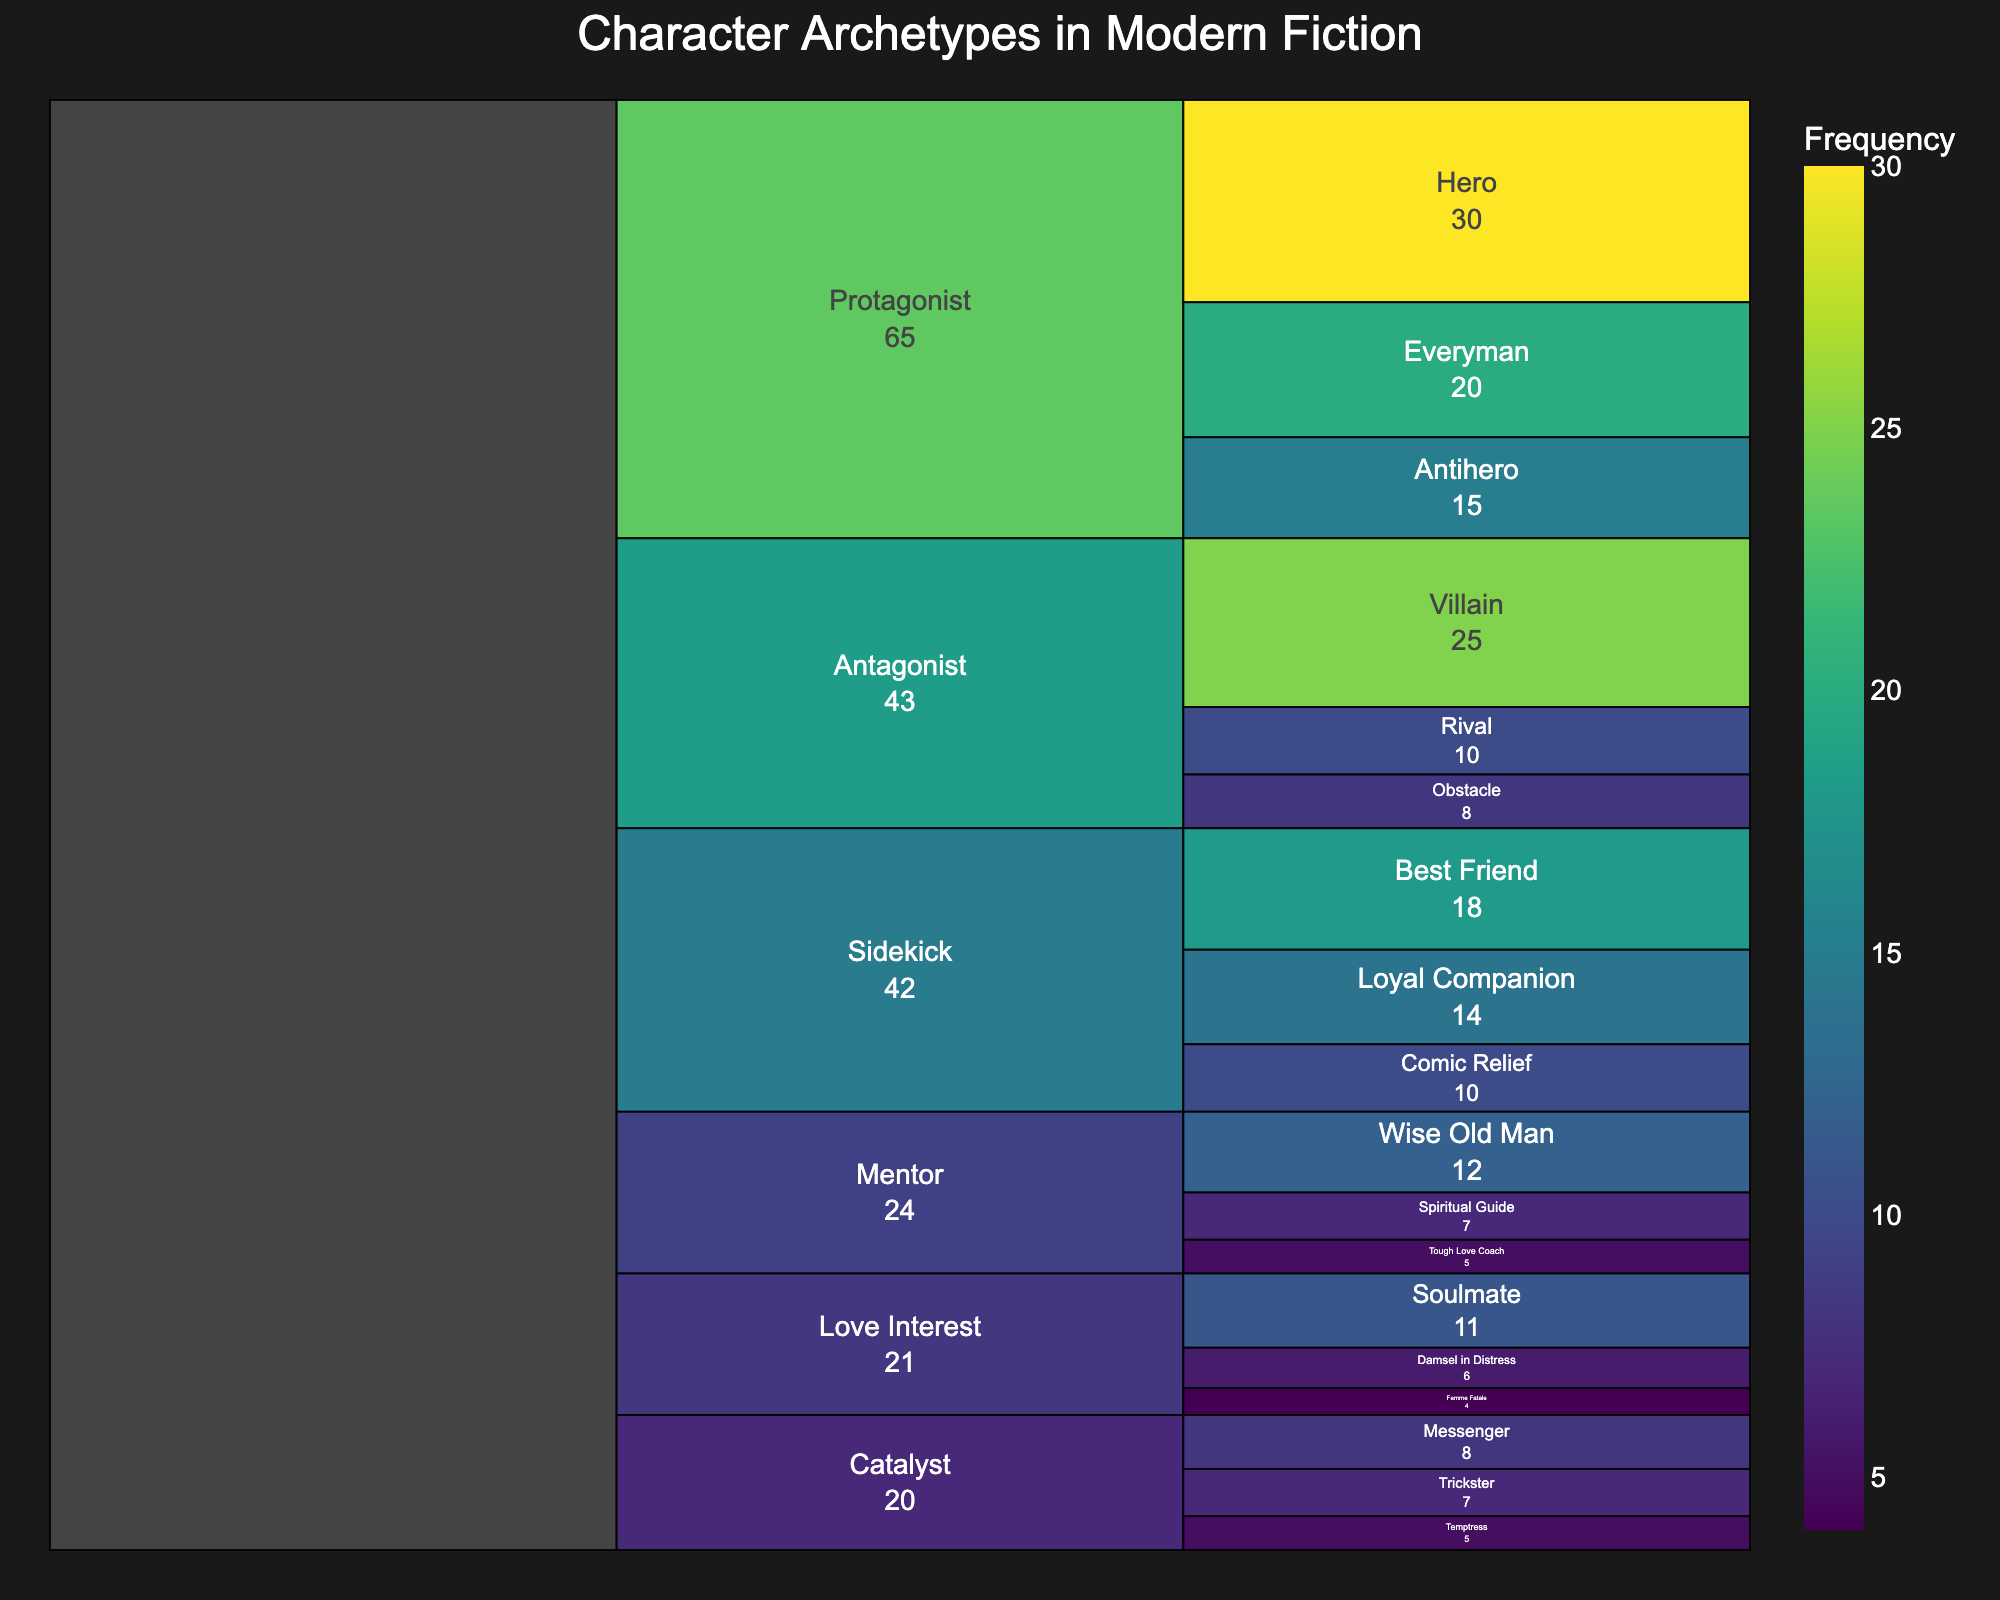How many subtypes exist under the "Protagonist" archetype? The "Protagonist" archetype has three subtypes displayed: Hero, Antihero, and Everyman.
Answer: 3 What is the frequency of the "Antihero" subtype? By looking at the "Protagonist" section, the frequency of the Antihero subtype is displayed as 15.
Answer: 15 Which archetype has the highest total frequency? Summing up the frequencies for each archetype: Protagonist (30+15+20=65), Antagonist (25+10+8=43), Mentor (12+7+5=24), Sidekick (18+10+14=42), Love Interest (6+4+11=21), Catalyst (8+5+7=20). The "Protagonist" archetype has the highest total frequency of 65.
Answer: Protagonist What is the total frequency of all subtypes under the "Sidekick" archetype? The frequency of the subtypes is as follows: Best Friend (18), Comic Relief (10), Loyal Companion (14). Summing these gives: 18 + 10 + 14 = 42.
Answer: 42 Which subtype has the lowest frequency, and what is its value? Looking through all subtypes, the "Femme Fatale" under the "Love Interest" archetype has the lowest frequency with a value of 4.
Answer: Femme Fatale (4) How does the frequency of the "Villain" subtype compare to the entire "Mentor" archetype? The frequency of the Villain subtype is 25, the total frequency of the Mentor archetype is 12 + 7 + 5 = 24. So, the Villain subtype has a higher frequency (25) than the entire Mentor archetype (24).
Answer: Villain > Mentor What is the average frequency of subtypes under the "Love Interest" archetype? The subtypes are Damsel in Distress (6), Femme Fatale (4), and Soulmate (11). The average is calculated as: (6 + 4 + 11) / 3 = 21 / 3 = 7.
Answer: 7 How many archetypes have a total frequency exceeding 30? Summing up the frequencies for each archetype, "Protagonist" (65) and "Sidekick" (42) exceed 30. So, there are 2 archetypes in total.
Answer: 2 What is the combined frequency of "Hero" and "Villain" subtypes? The frequency of Hero is 30, and the frequency of Villain is 25. The combined frequency is 30 + 25 = 55.
Answer: 55 Which archetype has the highest number of subtypes and which? Tallying the subtypes, both "Protagonist" and "Sidekick" have 3 subtypes each, which is the highest.
Answer: Protagonist and Sidekick 